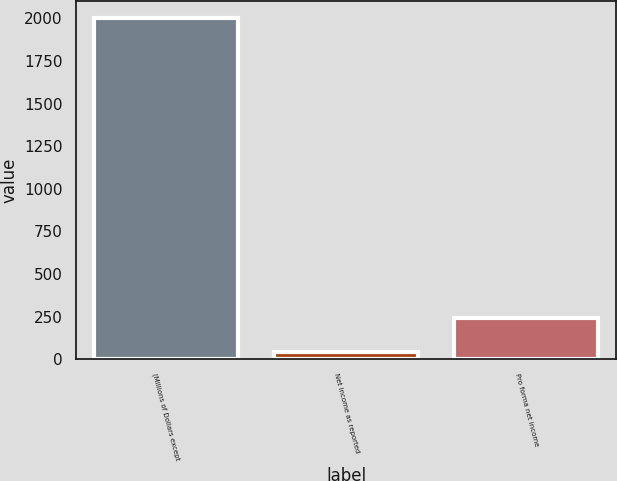<chart> <loc_0><loc_0><loc_500><loc_500><bar_chart><fcel>(Millions of Dollars except<fcel>Net income as reported<fcel>Pro forma net income<nl><fcel>2003<fcel>45<fcel>240.8<nl></chart> 